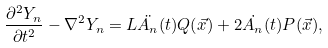Convert formula to latex. <formula><loc_0><loc_0><loc_500><loc_500>\frac { \partial ^ { 2 } Y _ { n } } { \partial t ^ { 2 } } - \nabla ^ { 2 } Y _ { n } = L \ddot { A _ { n } } ( t ) Q ( \vec { x } ) + 2 \dot { A _ { n } } ( t ) P ( \vec { x } ) ,</formula> 